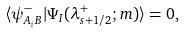Convert formula to latex. <formula><loc_0><loc_0><loc_500><loc_500>\langle \psi ^ { - } _ { A _ { i } B } | \Psi _ { I } ( \lambda _ { s + 1 / 2 } ^ { + } ; m ) \rangle = 0 ,</formula> 